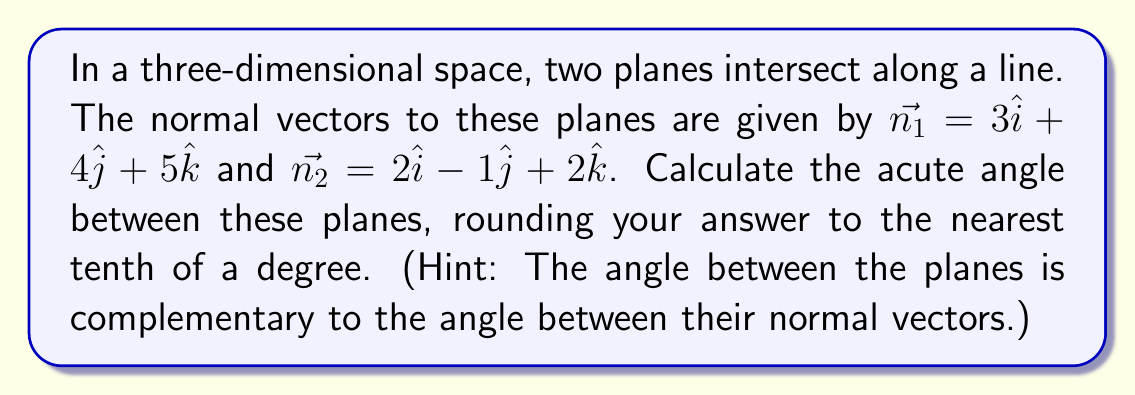Teach me how to tackle this problem. To find the angle between two intersecting planes, we can use the following steps:

1) The angle between two planes is complementary to the angle between their normal vectors. So, we first find the angle between the normal vectors.

2) The angle $\theta$ between two vectors $\vec{a}$ and $\vec{b}$ is given by the formula:

   $$\cos \theta = \frac{\vec{a} \cdot \vec{b}}{|\vec{a}| |\vec{b}|}$$

3) Let's calculate the dot product $\vec{n_1} \cdot \vec{n_2}$:
   $$(3)(2) + (4)(-1) + (5)(2) = 6 - 4 + 10 = 12$$

4) Now, let's calculate the magnitudes of the vectors:
   $$|\vec{n_1}| = \sqrt{3^2 + 4^2 + 5^2} = \sqrt{50}$$
   $$|\vec{n_2}| = \sqrt{2^2 + (-1)^2 + 2^2} = \sqrt{9} = 3$$

5) Substituting into the formula:

   $$\cos \theta = \frac{12}{\sqrt{50} \cdot 3} = \frac{12}{3\sqrt{50}} = \frac{4}{\sqrt{50}}$$

6) To find $\theta$, we take the inverse cosine (arccos) of both sides:

   $$\theta = \arccos(\frac{4}{\sqrt{50}}) \approx 0.9273 \text{ radians}$$

7) Convert to degrees:

   $$0.9273 \text{ radians} \cdot \frac{180^{\circ}}{\pi} \approx 53.1^{\circ}$$

8) The angle between the planes is complementary to this angle:

   $$90^{\circ} - 53.1^{\circ} = 36.9^{\circ}$$

9) Rounding to the nearest tenth of a degree gives $36.9^{\circ}$.
Answer: $36.9^{\circ}$ 